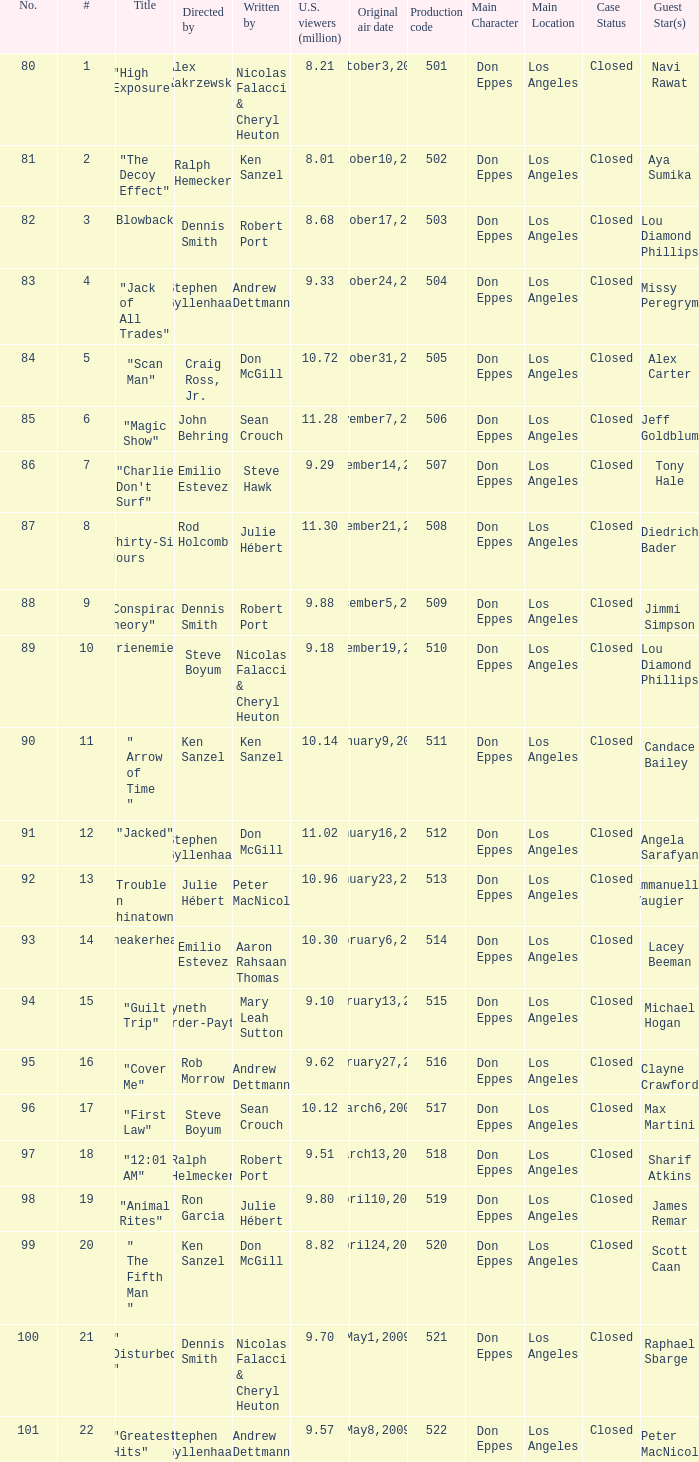What episode number was directed by Craig Ross, Jr. 5.0. Would you mind parsing the complete table? {'header': ['No.', '#', 'Title', 'Directed by', 'Written by', 'U.S. viewers (million)', 'Original air date', 'Production code', 'Main Character', 'Main Location', 'Case Status', 'Guest Star(s)'], 'rows': [['80', '1', '"High Exposure"', 'Alex Zakrzewski', 'Nicolas Falacci & Cheryl Heuton', '8.21', 'October3,2008', '501', 'Don Eppes', 'Los Angeles', 'Closed', 'Navi Rawat'], ['81', '2', '"The Decoy Effect"', 'Ralph Hemecker', 'Ken Sanzel', '8.01', 'October10,2008', '502', 'Don Eppes', 'Los Angeles', 'Closed', 'Aya Sumika'], ['82', '3', '"Blowback"', 'Dennis Smith', 'Robert Port', '8.68', 'October17,2008', '503', 'Don Eppes', 'Los Angeles', 'Closed', 'Lou Diamond Phillips'], ['83', '4', '"Jack of All Trades"', 'Stephen Gyllenhaal', 'Andrew Dettmann', '9.33', 'October24,2008', '504', 'Don Eppes', 'Los Angeles', 'Closed', 'Missy Peregrym'], ['84', '5', '"Scan Man"', 'Craig Ross, Jr.', 'Don McGill', '10.72', 'October31,2008', '505', 'Don Eppes', 'Los Angeles', 'Closed', 'Alex Carter'], ['85', '6', '"Magic Show"', 'John Behring', 'Sean Crouch', '11.28', 'November7,2008', '506', 'Don Eppes', 'Los Angeles', 'Closed', 'Jeff Goldblum'], ['86', '7', '"Charlie Don\'t Surf"', 'Emilio Estevez', 'Steve Hawk', '9.29', 'November14,2008', '507', 'Don Eppes', 'Los Angeles', 'Closed', 'Tony Hale'], ['87', '8', '" Thirty-Six Hours "', 'Rod Holcomb', 'Julie Hébert', '11.30', 'November21,2008', '508', 'Don Eppes', 'Los Angeles', 'Closed', 'Diedrich Bader'], ['88', '9', '"Conspiracy Theory"', 'Dennis Smith', 'Robert Port', '9.88', 'December5,2008', '509', 'Don Eppes', 'Los Angeles', 'Closed', 'Jimmi Simpson'], ['89', '10', '"Frienemies"', 'Steve Boyum', 'Nicolas Falacci & Cheryl Heuton', '9.18', 'December19,2008', '510', 'Don Eppes', 'Los Angeles', 'Closed', 'Lou Diamond Phillips'], ['90', '11', '" Arrow of Time "', 'Ken Sanzel', 'Ken Sanzel', '10.14', 'January9,2009', '511', 'Don Eppes', 'Los Angeles', 'Closed', 'Candace Bailey'], ['91', '12', '"Jacked"', 'Stephen Gyllenhaal', 'Don McGill', '11.02', 'January16,2009', '512', 'Don Eppes', 'Los Angeles', 'Closed', 'Angela Sarafyan'], ['92', '13', '"Trouble In Chinatown"', 'Julie Hébert', 'Peter MacNicol', '10.96', 'January23,2009', '513', 'Don Eppes', 'Los Angeles', 'Closed', 'Emmanuelle Vaugier'], ['93', '14', '"Sneakerhead"', 'Emilio Estevez', 'Aaron Rahsaan Thomas', '10.30', 'February6,2009', '514', 'Don Eppes', 'Los Angeles', 'Closed', 'Lacey Beeman'], ['94', '15', '"Guilt Trip"', 'Gwyneth Horder-Payton', 'Mary Leah Sutton', '9.10', 'February13,2009', '515', 'Don Eppes', 'Los Angeles', 'Closed', 'Michael Hogan'], ['95', '16', '"Cover Me"', 'Rob Morrow', 'Andrew Dettmann', '9.62', 'February27,2009', '516', 'Don Eppes', 'Los Angeles', 'Closed', 'Clayne Crawford'], ['96', '17', '"First Law"', 'Steve Boyum', 'Sean Crouch', '10.12', 'March6,2009', '517', 'Don Eppes', 'Los Angeles', 'Closed', 'Max Martini'], ['97', '18', '"12:01 AM"', 'Ralph Helmecker', 'Robert Port', '9.51', 'March13,2009', '518', 'Don Eppes', 'Los Angeles', 'Closed', 'Sharif Atkins'], ['98', '19', '"Animal Rites"', 'Ron Garcia', 'Julie Hébert', '9.80', 'April10,2009', '519', 'Don Eppes', 'Los Angeles', 'Closed', 'James Remar'], ['99', '20', '" The Fifth Man "', 'Ken Sanzel', 'Don McGill', '8.82', 'April24,2009', '520', 'Don Eppes', 'Los Angeles', 'Closed', 'Scott Caan'], ['100', '21', '" Disturbed "', 'Dennis Smith', 'Nicolas Falacci & Cheryl Heuton', '9.70', 'May1,2009', '521', 'Don Eppes', 'Los Angeles', 'Closed', 'Raphael Sbarge'], ['101', '22', '"Greatest Hits"', 'Stephen Gyllenhaal', 'Andrew Dettmann', '9.57', 'May8,2009', '522', 'Don Eppes', 'Los Angeles', 'Closed', 'Peter MacNicol']]} 